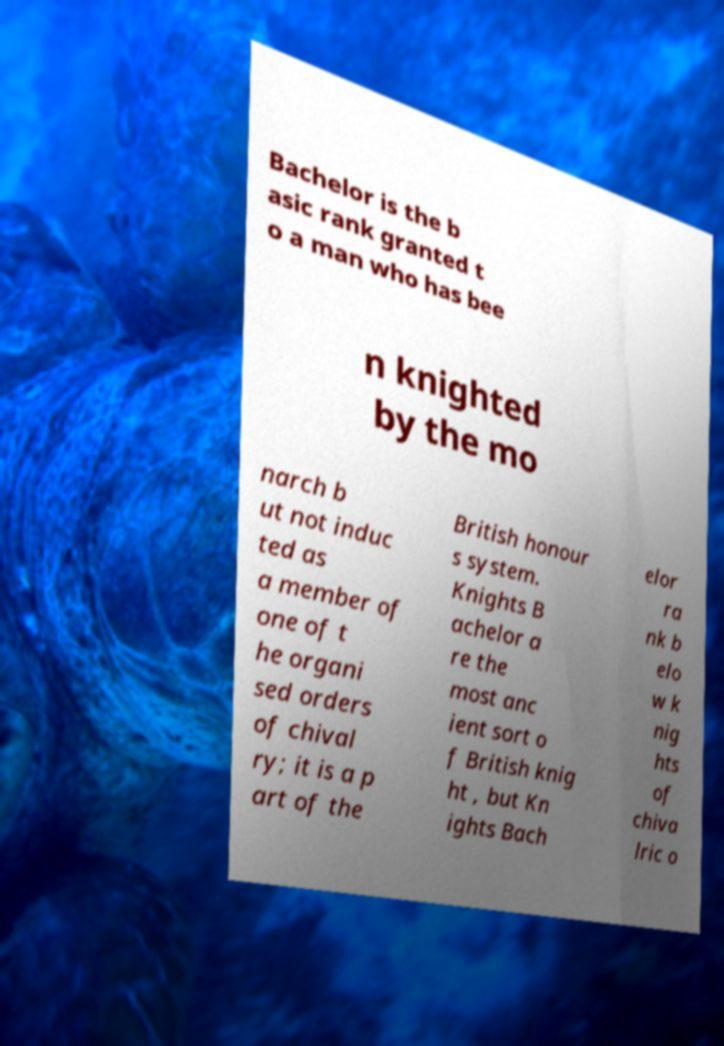I need the written content from this picture converted into text. Can you do that? Bachelor is the b asic rank granted t o a man who has bee n knighted by the mo narch b ut not induc ted as a member of one of t he organi sed orders of chival ry; it is a p art of the British honour s system. Knights B achelor a re the most anc ient sort o f British knig ht , but Kn ights Bach elor ra nk b elo w k nig hts of chiva lric o 